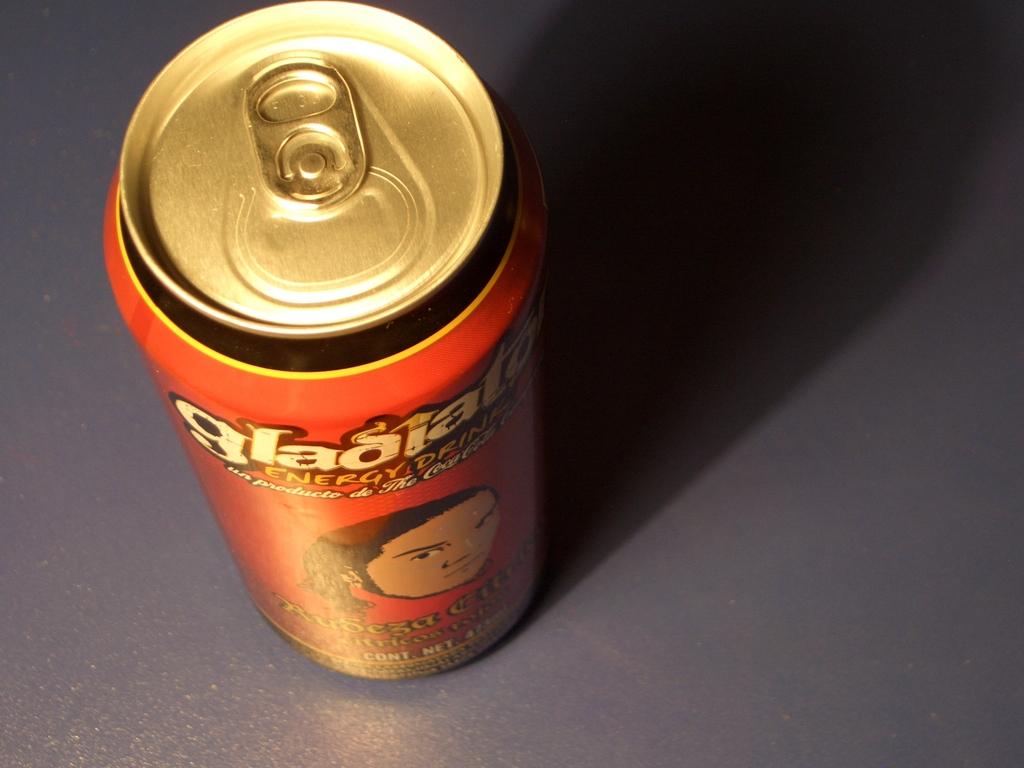What type of drink is in this can?
Offer a very short reply. Energy drink. 